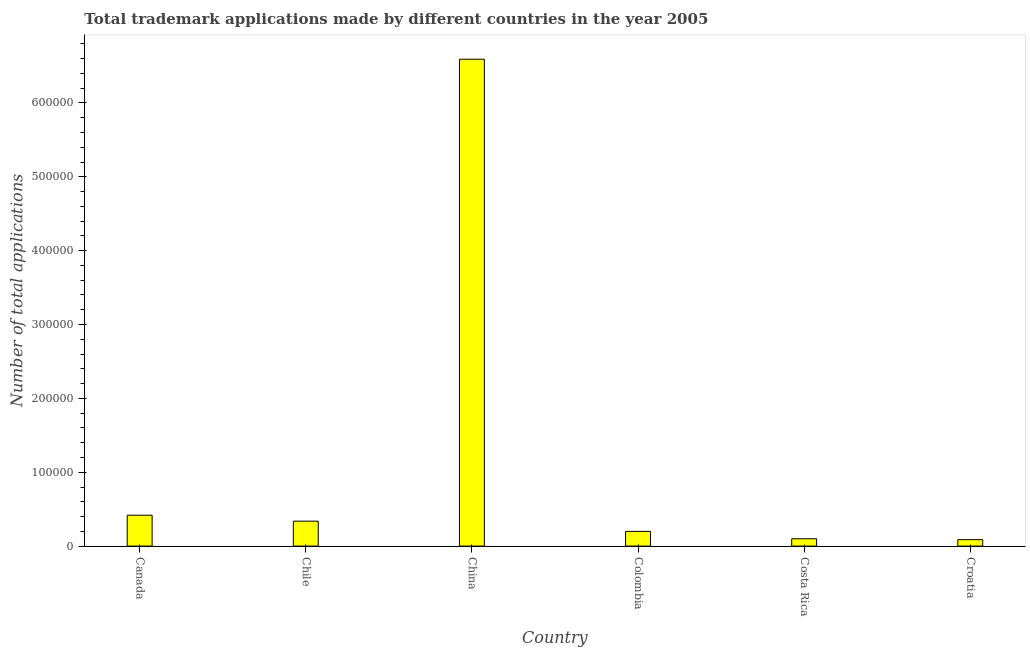Does the graph contain grids?
Provide a succinct answer. No. What is the title of the graph?
Offer a terse response. Total trademark applications made by different countries in the year 2005. What is the label or title of the Y-axis?
Provide a succinct answer. Number of total applications. What is the number of trademark applications in China?
Provide a short and direct response. 6.59e+05. Across all countries, what is the maximum number of trademark applications?
Offer a terse response. 6.59e+05. Across all countries, what is the minimum number of trademark applications?
Make the answer very short. 8732. In which country was the number of trademark applications maximum?
Give a very brief answer. China. In which country was the number of trademark applications minimum?
Keep it short and to the point. Croatia. What is the sum of the number of trademark applications?
Keep it short and to the point. 7.73e+05. What is the difference between the number of trademark applications in Chile and Colombia?
Provide a succinct answer. 1.38e+04. What is the average number of trademark applications per country?
Keep it short and to the point. 1.29e+05. What is the median number of trademark applications?
Give a very brief answer. 2.68e+04. In how many countries, is the number of trademark applications greater than 120000 ?
Your answer should be very brief. 1. What is the ratio of the number of trademark applications in Colombia to that in Costa Rica?
Offer a terse response. 2.01. Is the difference between the number of trademark applications in Colombia and Croatia greater than the difference between any two countries?
Make the answer very short. No. What is the difference between the highest and the second highest number of trademark applications?
Your response must be concise. 6.17e+05. What is the difference between the highest and the lowest number of trademark applications?
Keep it short and to the point. 6.50e+05. How many bars are there?
Provide a succinct answer. 6. What is the difference between two consecutive major ticks on the Y-axis?
Keep it short and to the point. 1.00e+05. What is the Number of total applications of Canada?
Provide a succinct answer. 4.18e+04. What is the Number of total applications of Chile?
Give a very brief answer. 3.38e+04. What is the Number of total applications of China?
Keep it short and to the point. 6.59e+05. What is the Number of total applications of Colombia?
Give a very brief answer. 1.99e+04. What is the Number of total applications of Costa Rica?
Your answer should be compact. 9939. What is the Number of total applications in Croatia?
Provide a succinct answer. 8732. What is the difference between the Number of total applications in Canada and Chile?
Your answer should be compact. 8075. What is the difference between the Number of total applications in Canada and China?
Ensure brevity in your answer.  -6.17e+05. What is the difference between the Number of total applications in Canada and Colombia?
Provide a succinct answer. 2.19e+04. What is the difference between the Number of total applications in Canada and Costa Rica?
Your answer should be very brief. 3.19e+04. What is the difference between the Number of total applications in Canada and Croatia?
Provide a succinct answer. 3.31e+04. What is the difference between the Number of total applications in Chile and China?
Provide a succinct answer. -6.25e+05. What is the difference between the Number of total applications in Chile and Colombia?
Make the answer very short. 1.38e+04. What is the difference between the Number of total applications in Chile and Costa Rica?
Your response must be concise. 2.38e+04. What is the difference between the Number of total applications in Chile and Croatia?
Your answer should be very brief. 2.50e+04. What is the difference between the Number of total applications in China and Colombia?
Offer a terse response. 6.39e+05. What is the difference between the Number of total applications in China and Costa Rica?
Your answer should be very brief. 6.49e+05. What is the difference between the Number of total applications in China and Croatia?
Your answer should be very brief. 6.50e+05. What is the difference between the Number of total applications in Colombia and Costa Rica?
Offer a very short reply. 9998. What is the difference between the Number of total applications in Colombia and Croatia?
Your answer should be very brief. 1.12e+04. What is the difference between the Number of total applications in Costa Rica and Croatia?
Give a very brief answer. 1207. What is the ratio of the Number of total applications in Canada to that in Chile?
Provide a short and direct response. 1.24. What is the ratio of the Number of total applications in Canada to that in China?
Make the answer very short. 0.06. What is the ratio of the Number of total applications in Canada to that in Colombia?
Provide a succinct answer. 2.1. What is the ratio of the Number of total applications in Canada to that in Costa Rica?
Your answer should be very brief. 4.21. What is the ratio of the Number of total applications in Canada to that in Croatia?
Keep it short and to the point. 4.79. What is the ratio of the Number of total applications in Chile to that in China?
Ensure brevity in your answer.  0.05. What is the ratio of the Number of total applications in Chile to that in Colombia?
Give a very brief answer. 1.69. What is the ratio of the Number of total applications in Chile to that in Costa Rica?
Make the answer very short. 3.4. What is the ratio of the Number of total applications in Chile to that in Croatia?
Provide a short and direct response. 3.87. What is the ratio of the Number of total applications in China to that in Colombia?
Provide a succinct answer. 33.06. What is the ratio of the Number of total applications in China to that in Costa Rica?
Provide a succinct answer. 66.32. What is the ratio of the Number of total applications in China to that in Croatia?
Provide a succinct answer. 75.49. What is the ratio of the Number of total applications in Colombia to that in Costa Rica?
Your answer should be compact. 2.01. What is the ratio of the Number of total applications in Colombia to that in Croatia?
Keep it short and to the point. 2.28. What is the ratio of the Number of total applications in Costa Rica to that in Croatia?
Make the answer very short. 1.14. 